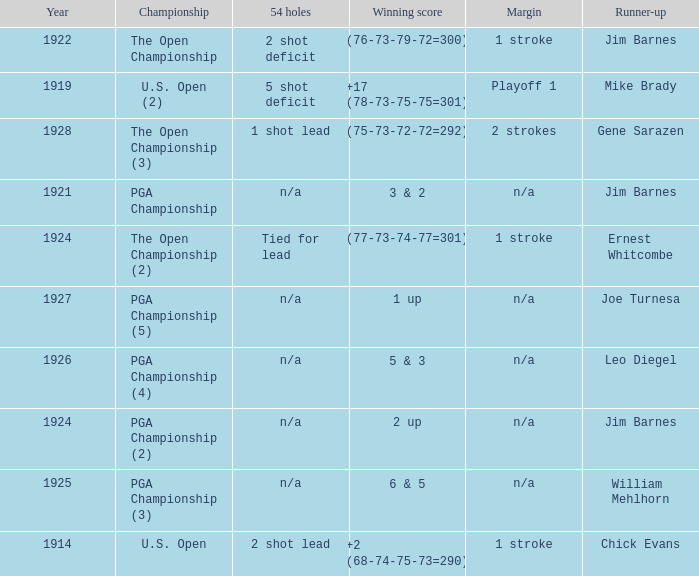HOW MANY YEARS WAS IT FOR THE SCORE (76-73-79-72=300)? 1.0. 